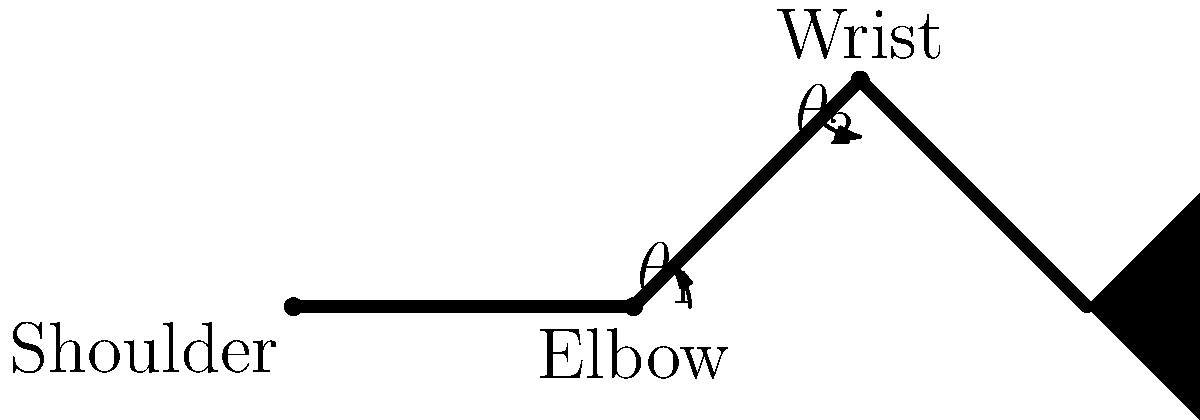In the diagram showing an auctioneer's arm during bidding, what is the relationship between the shoulder angle ($\theta_1$) and the wrist angle ($\theta_2$) that allows for the most efficient and visible bidding motion? To understand the biomechanics of an auctioneer's arm motion during bidding, we need to consider the following steps:

1. The shoulder angle ($\theta_1$) represents the angle between the upper arm and the vertical axis.
2. The wrist angle ($\theta_2$) represents the angle between the forearm and the bidding paddle.
3. Efficient bidding motion requires a balance between visibility and energy conservation.
4. A larger shoulder angle ($\theta_1$) increases visibility but requires more energy.
5. A smaller wrist angle ($\theta_2$) allows for quicker, more precise movements.
6. The most efficient motion typically involves a moderate shoulder angle (around 45°) and a relatively small wrist angle (around 15-30°).
7. This combination allows for good visibility while minimizing fatigue during prolonged auctions.
8. The relationship can be expressed as: $\theta_1 \approx 3\theta_2$ for optimal efficiency and visibility.

This relationship ensures that the bidding paddle remains visible to the audience while allowing the auctioneer to maintain the motion for extended periods without excessive strain.
Answer: $\theta_1 \approx 3\theta_2$ 